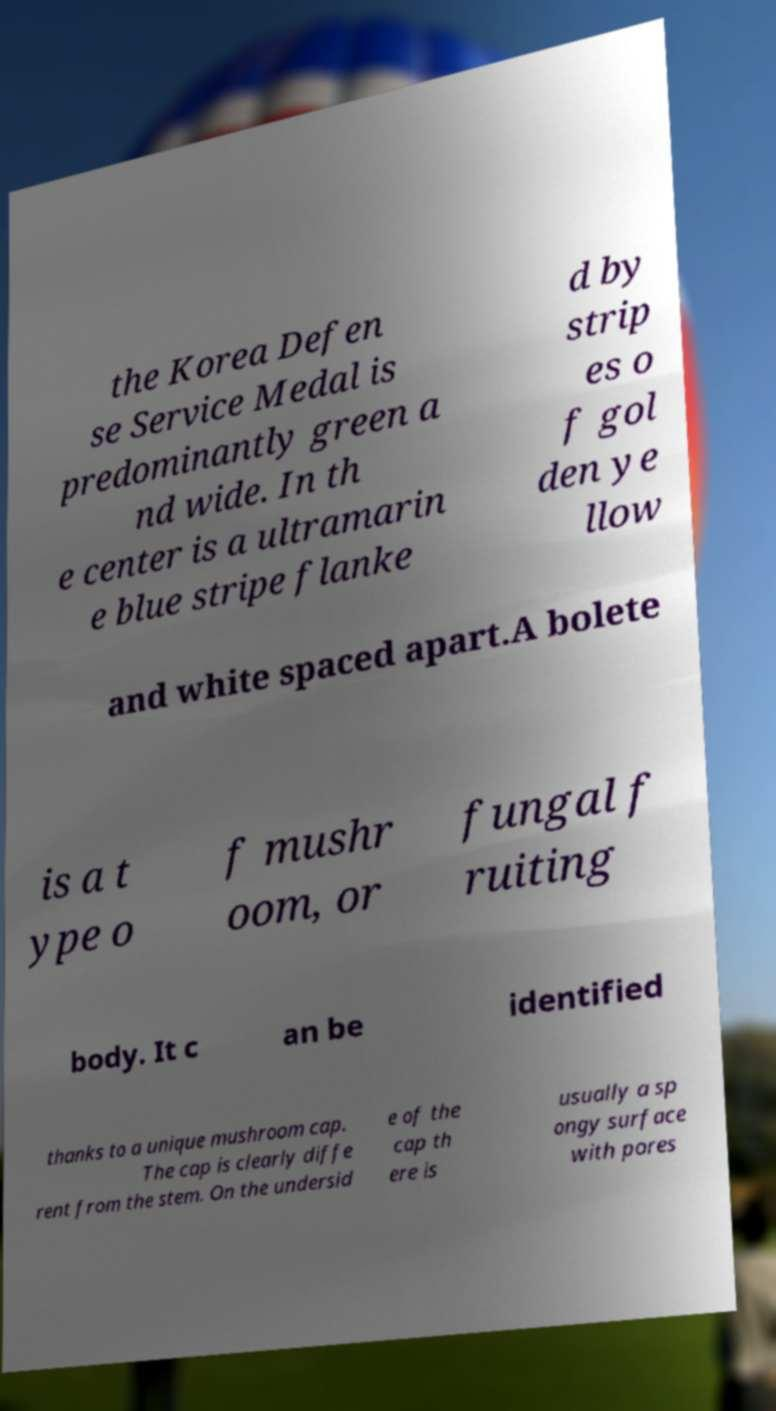Can you accurately transcribe the text from the provided image for me? the Korea Defen se Service Medal is predominantly green a nd wide. In th e center is a ultramarin e blue stripe flanke d by strip es o f gol den ye llow and white spaced apart.A bolete is a t ype o f mushr oom, or fungal f ruiting body. It c an be identified thanks to a unique mushroom cap. The cap is clearly diffe rent from the stem. On the undersid e of the cap th ere is usually a sp ongy surface with pores 